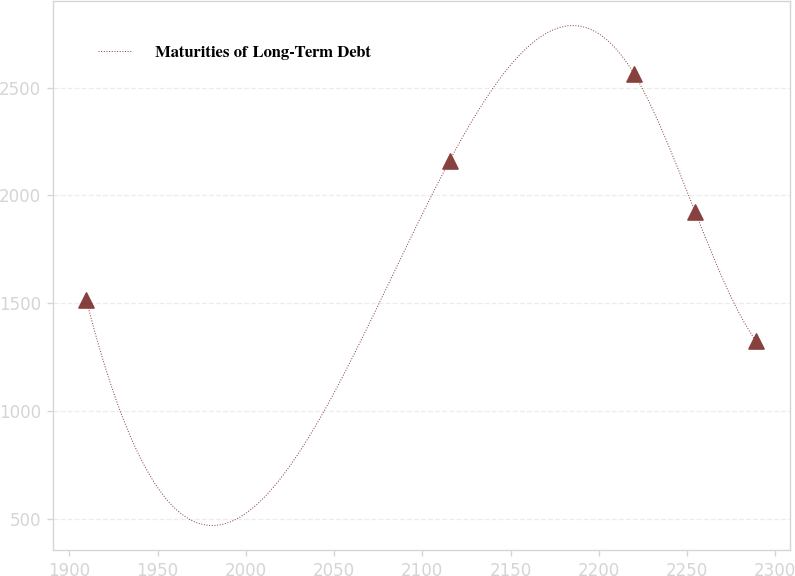Convert chart. <chart><loc_0><loc_0><loc_500><loc_500><line_chart><ecel><fcel>Maturities of Long-Term Debt<nl><fcel>1909.65<fcel>1514.58<nl><fcel>2115.52<fcel>2161.24<nl><fcel>2219.91<fcel>2564.69<nl><fcel>2254.52<fcel>1924.65<nl><fcel>2289.13<fcel>1323.73<nl></chart> 